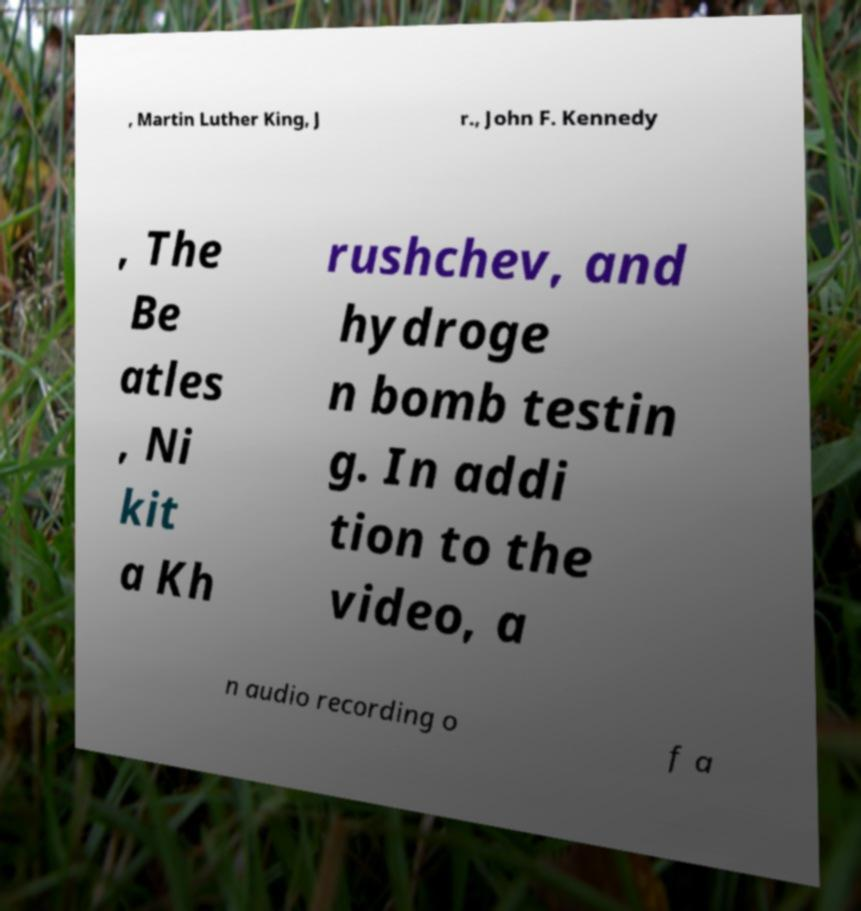There's text embedded in this image that I need extracted. Can you transcribe it verbatim? , Martin Luther King, J r., John F. Kennedy , The Be atles , Ni kit a Kh rushchev, and hydroge n bomb testin g. In addi tion to the video, a n audio recording o f a 